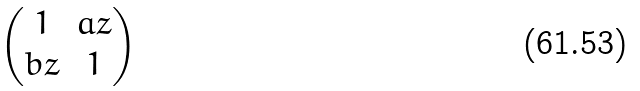Convert formula to latex. <formula><loc_0><loc_0><loc_500><loc_500>\begin{pmatrix} 1 & a z \\ b z & 1 \end{pmatrix}</formula> 